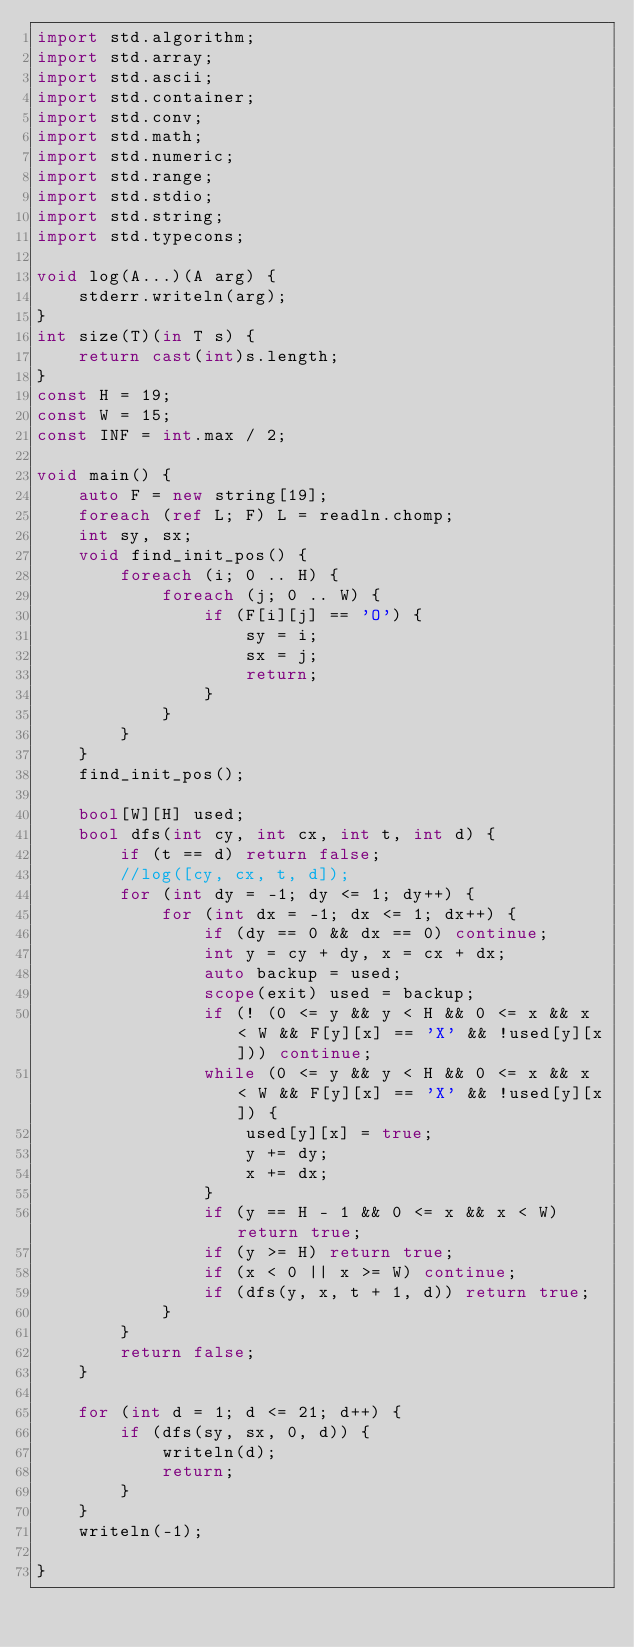Convert code to text. <code><loc_0><loc_0><loc_500><loc_500><_D_>import std.algorithm;
import std.array;
import std.ascii;
import std.container;
import std.conv;
import std.math;
import std.numeric;
import std.range;
import std.stdio;
import std.string;
import std.typecons;

void log(A...)(A arg) {
    stderr.writeln(arg);
}
int size(T)(in T s) {
    return cast(int)s.length;
}
const H = 19;
const W = 15;
const INF = int.max / 2;

void main() {
    auto F = new string[19];
    foreach (ref L; F) L = readln.chomp;
    int sy, sx;
    void find_init_pos() {
        foreach (i; 0 .. H) {
            foreach (j; 0 .. W) {
                if (F[i][j] == 'O') {
                    sy = i;
                    sx = j;
                    return;
                }
            }
        }
    }
    find_init_pos();

    bool[W][H] used;
    bool dfs(int cy, int cx, int t, int d) {
        if (t == d) return false;
        //log([cy, cx, t, d]);
        for (int dy = -1; dy <= 1; dy++) {
            for (int dx = -1; dx <= 1; dx++) {
                if (dy == 0 && dx == 0) continue;
                int y = cy + dy, x = cx + dx;
                auto backup = used;
                scope(exit) used = backup;
                if (! (0 <= y && y < H && 0 <= x && x < W && F[y][x] == 'X' && !used[y][x])) continue;
                while (0 <= y && y < H && 0 <= x && x < W && F[y][x] == 'X' && !used[y][x]) {
                    used[y][x] = true;
                    y += dy;
                    x += dx;
                }
                if (y == H - 1 && 0 <= x && x < W) return true;
                if (y >= H) return true;
                if (x < 0 || x >= W) continue;
                if (dfs(y, x, t + 1, d)) return true;
            }
        }
        return false;
    }

    for (int d = 1; d <= 21; d++) {
        if (dfs(sy, sx, 0, d)) {
            writeln(d);
            return;
        }
    }
    writeln(-1);

}</code> 